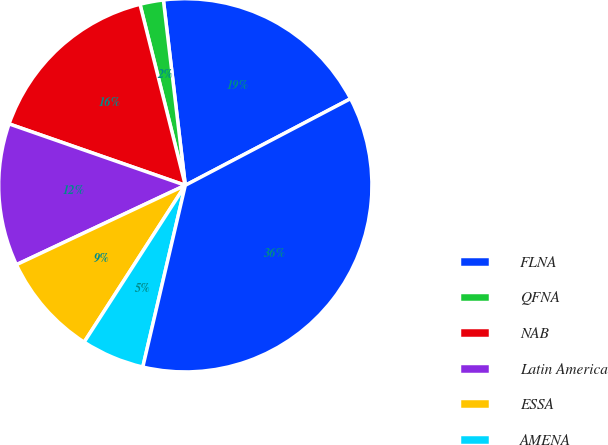<chart> <loc_0><loc_0><loc_500><loc_500><pie_chart><fcel>FLNA<fcel>QFNA<fcel>NAB<fcel>Latin America<fcel>ESSA<fcel>AMENA<fcel>Total division<nl><fcel>19.19%<fcel>2.03%<fcel>15.76%<fcel>12.33%<fcel>8.89%<fcel>5.46%<fcel>36.34%<nl></chart> 